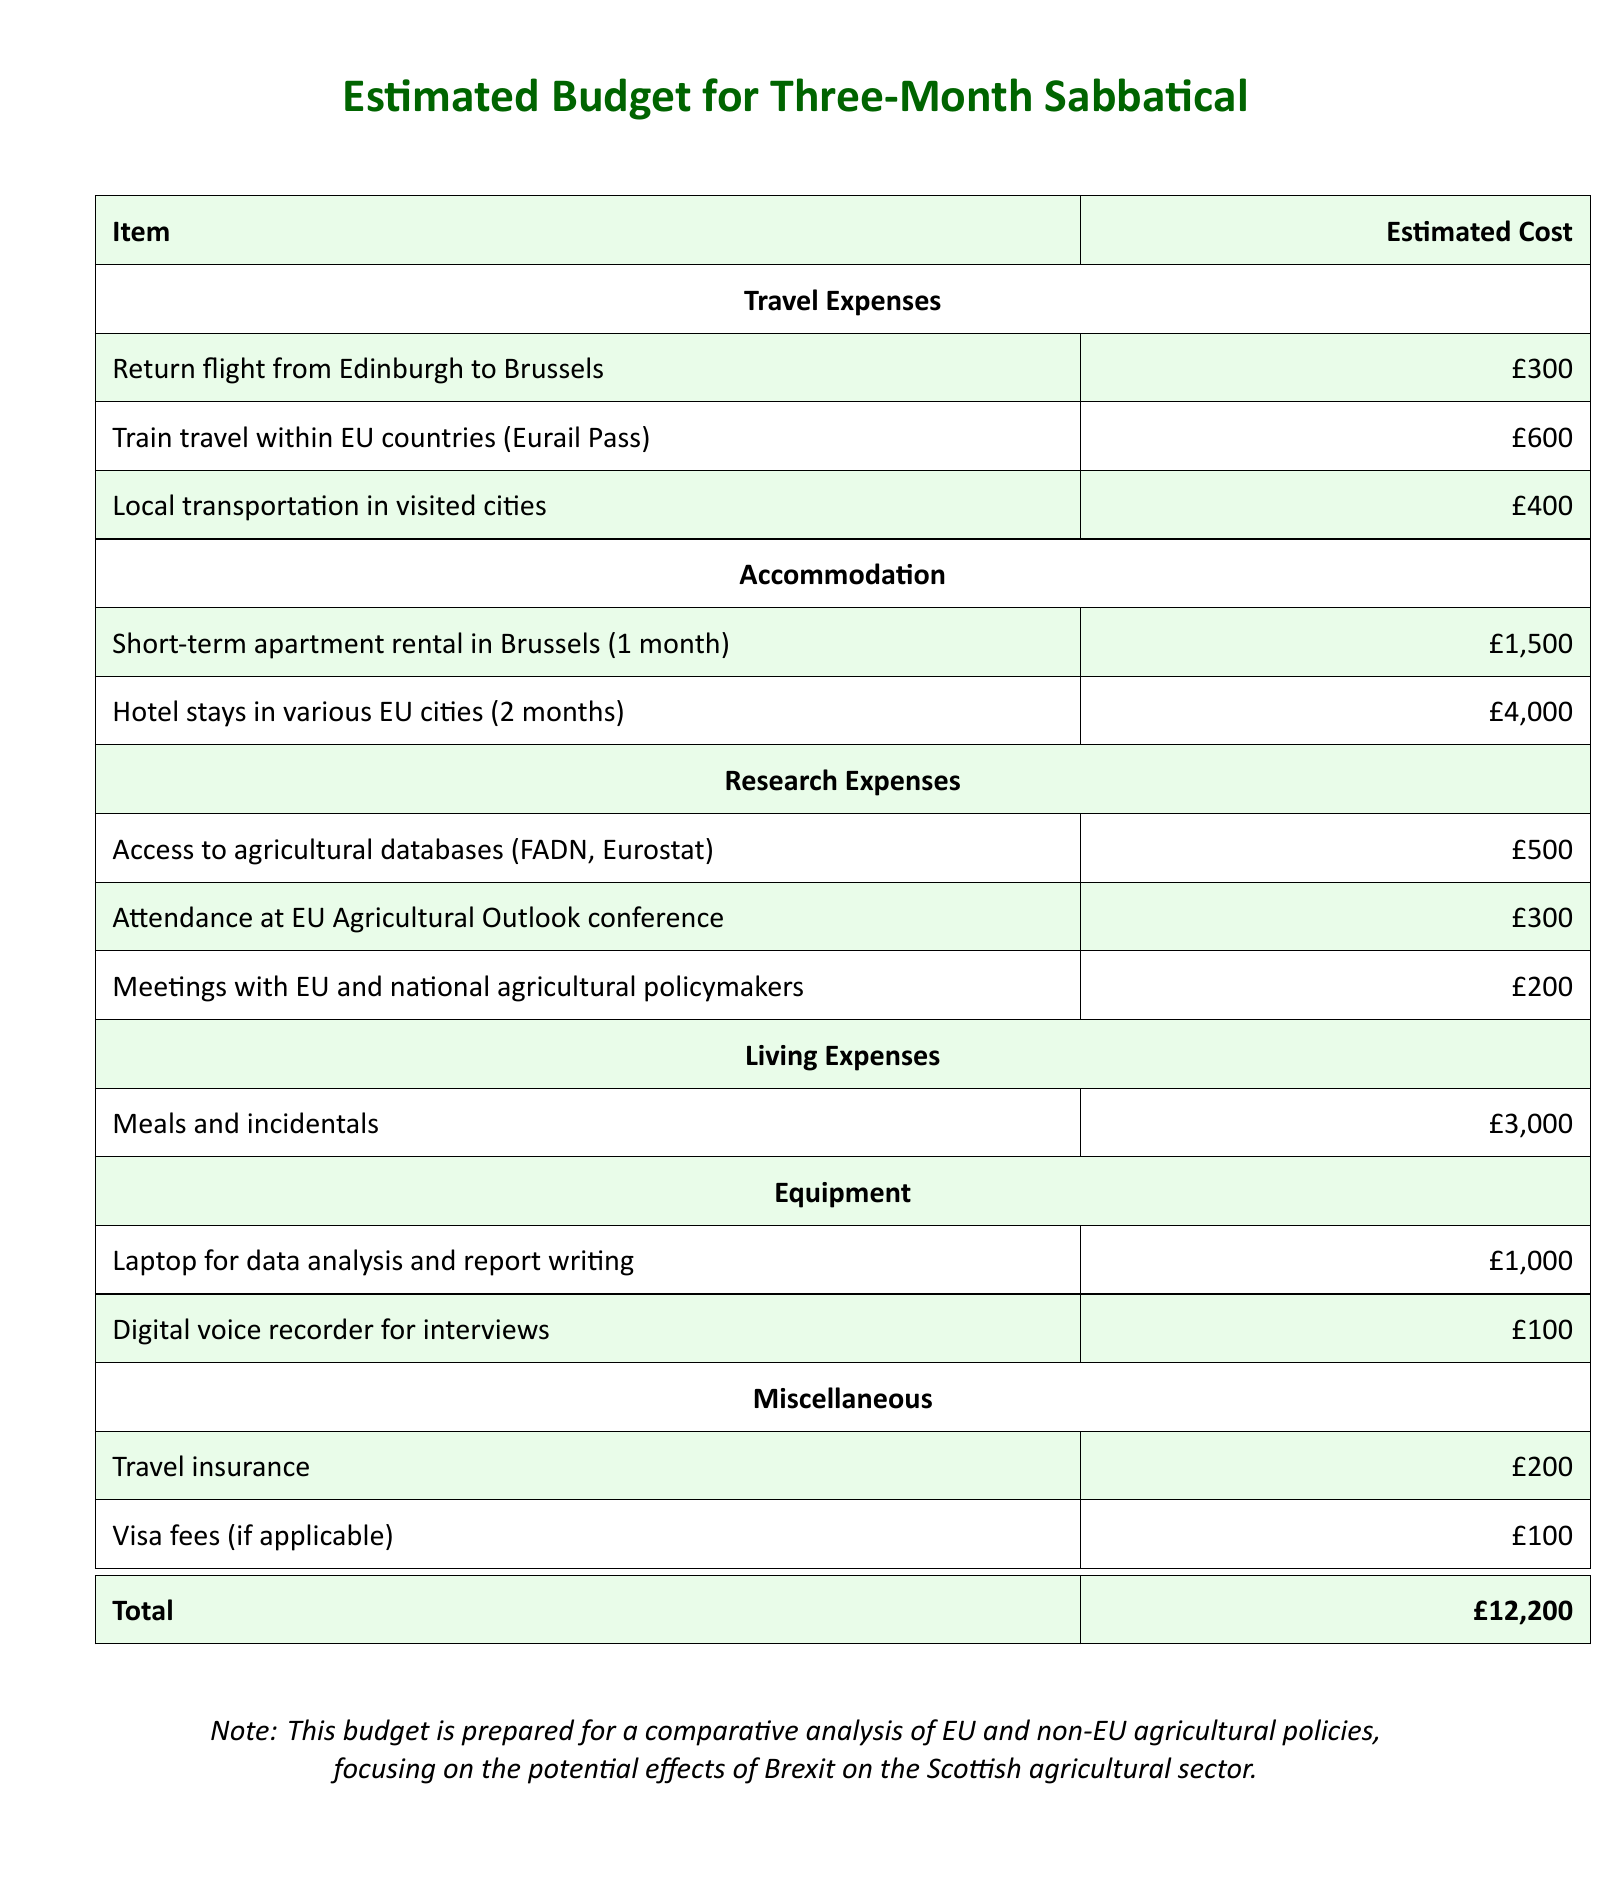What is the total estimated cost? The total cost is provided at the end of the document as £12,200.
Answer: £12,200 How much does the return flight from Edinburgh to Brussels cost? The cost for the return flight is listed in the travel expenses section of the document as £300.
Answer: £300 What is the estimated cost for meals and incidentals? The estimated cost for meals and incidentals is specified under living expenses as £3,000.
Answer: £3,000 How many months of hotel stays are included in the accommodation cost? The document mentions a duration of 2 months for hotel stays in various EU cities.
Answer: 2 months What is the cost associated with attending the EU Agricultural Outlook conference? The document lists the cost for attending the EU Agricultural Outlook conference under research expenses as £300.
Answer: £300 What type of equipment is included in the budget? The document lists equipment expenses, including a laptop and a digital voice recorder.
Answer: Laptop and digital voice recorder What is the estimated cost for train travel within EU countries? The budget mentions the cost for train travel within EU countries, specified as £600.
Answer: £600 Is there a budget line for travel insurance? The document includes a line item for travel insurance under miscellaneous expenses, showing an estimated cost.
Answer: Yes How much is allocated for access to agricultural databases? The budget for access to agricultural databases listed under research expenses is £500.
Answer: £500 